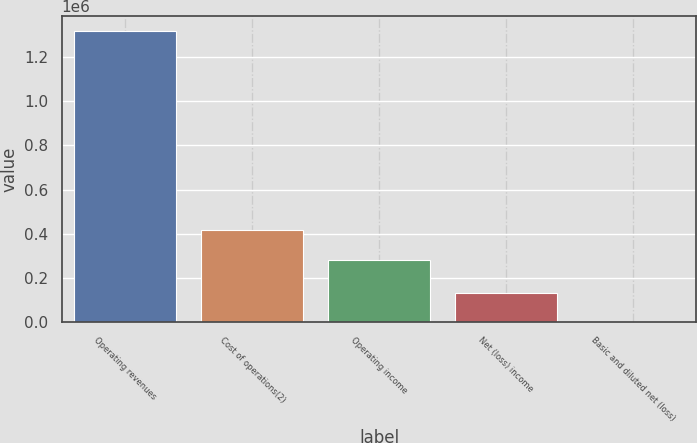Convert chart. <chart><loc_0><loc_0><loc_500><loc_500><bar_chart><fcel>Operating revenues<fcel>Cost of operations(2)<fcel>Operating income<fcel>Net (loss) income<fcel>Basic and diluted net (loss)<nl><fcel>1.31738e+06<fcel>415639<fcel>283901<fcel>131739<fcel>0.06<nl></chart> 